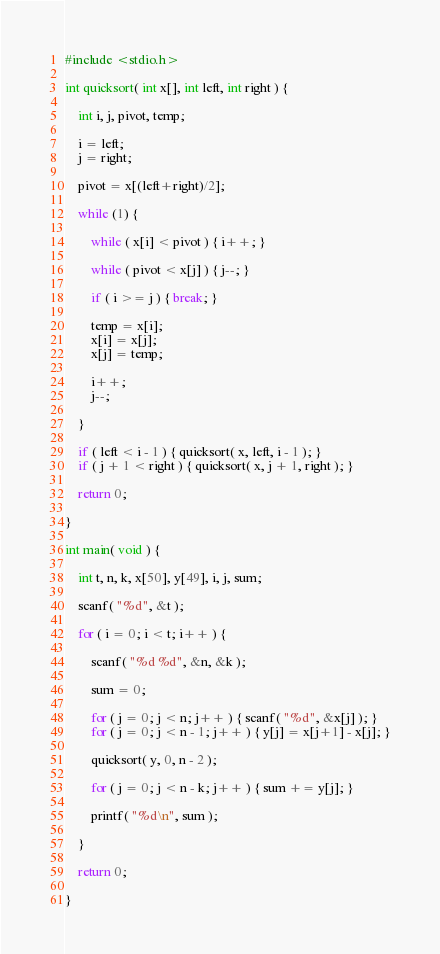<code> <loc_0><loc_0><loc_500><loc_500><_C_>#include <stdio.h>

int quicksort( int x[], int left, int right ) {
	
	int i, j, pivot, temp;
	
	i = left;
	j = right;
	
	pivot = x[(left+right)/2];
	
	while (1) {
	
		while ( x[i] < pivot ) { i++; }
		
		while ( pivot < x[j] ) { j--; }
		
		if ( i >= j ) { break; }
		
		temp = x[i];
		x[i] = x[j];
		x[j] = temp;
		
		i++;
		j--;
		
	}
	
	if ( left < i - 1 ) { quicksort( x, left, i - 1 ); }
    if ( j + 1 < right ) { quicksort( x, j + 1, right ); }
	
	return 0;
		
}

int main( void ) {

	int t, n, k, x[50], y[49], i, j, sum;
	
	scanf( "%d", &t );
	
	for ( i = 0; i < t; i++ ) {
	
		scanf( "%d %d", &n, &k );
		
		sum = 0;
	
		for ( j = 0; j < n; j++ ) { scanf( "%d", &x[j] ); }
		for ( j = 0; j < n - 1; j++ ) { y[j] = x[j+1] - x[j]; }
	
		quicksort( y, 0, n - 2 );
		
		for ( j = 0; j < n - k; j++ ) { sum += y[j]; }
		
		printf( "%d\n", sum );
		
	}
	
	return 0;

}</code> 